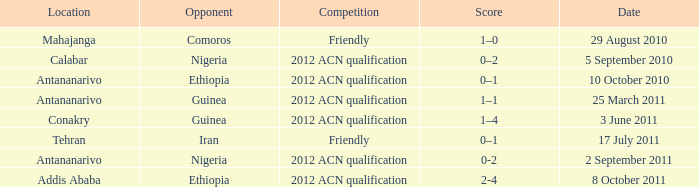Which competition was held at Addis Ababa? 2012 ACN qualification. 